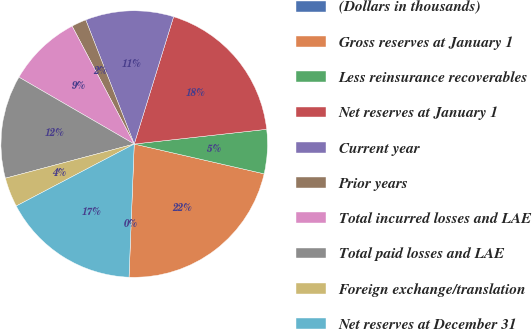<chart> <loc_0><loc_0><loc_500><loc_500><pie_chart><fcel>(Dollars in thousands)<fcel>Gross reserves at January 1<fcel>Less reinsurance recoverables<fcel>Net reserves at January 1<fcel>Current year<fcel>Prior years<fcel>Total incurred losses and LAE<fcel>Total paid losses and LAE<fcel>Foreign exchange/translation<fcel>Net reserves at December 31<nl><fcel>0.0%<fcel>22.03%<fcel>5.35%<fcel>18.46%<fcel>10.7%<fcel>1.79%<fcel>8.92%<fcel>12.49%<fcel>3.57%<fcel>16.68%<nl></chart> 